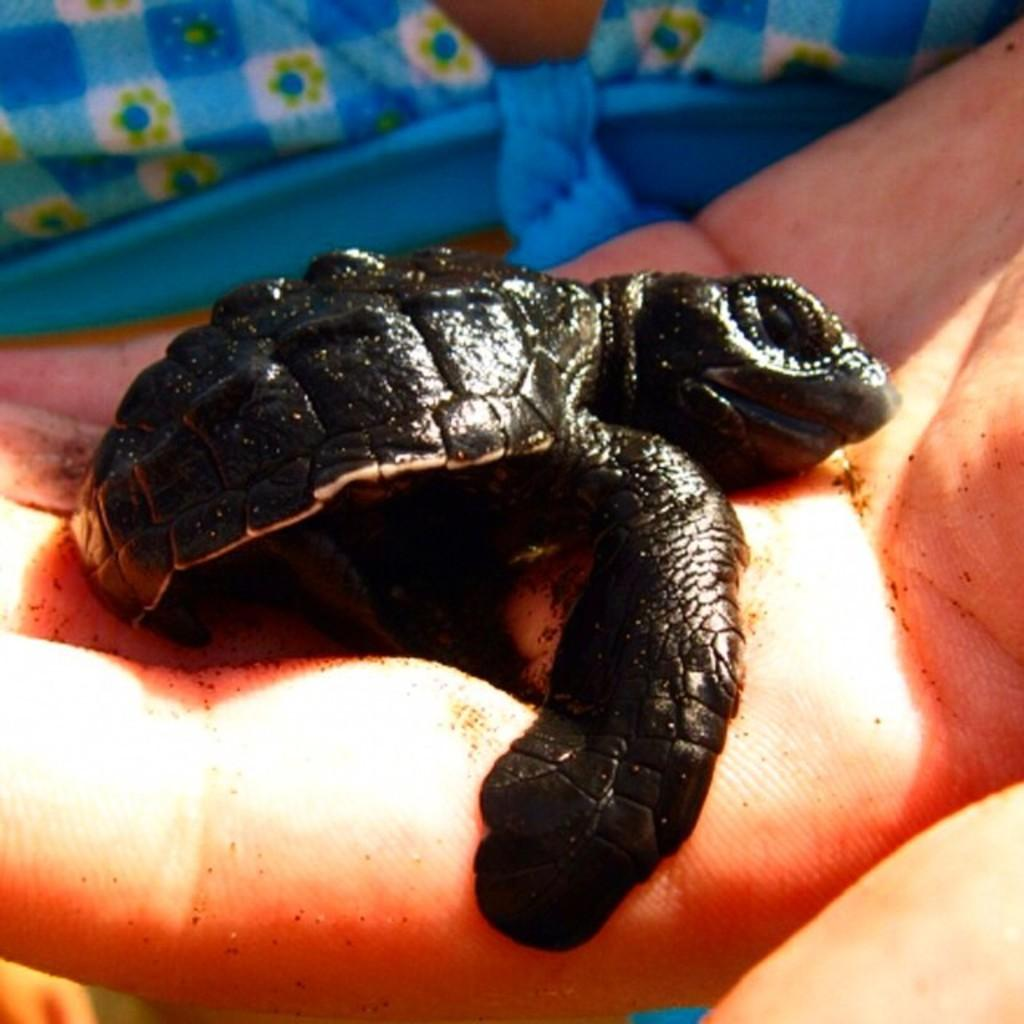What animal is on the person's hand in the image? There is a turtle on a person's hand in the image. What type of pain is the judge experiencing during the trip in the image? There is no judge or trip present in the image; it only features a turtle on a person's hand. 